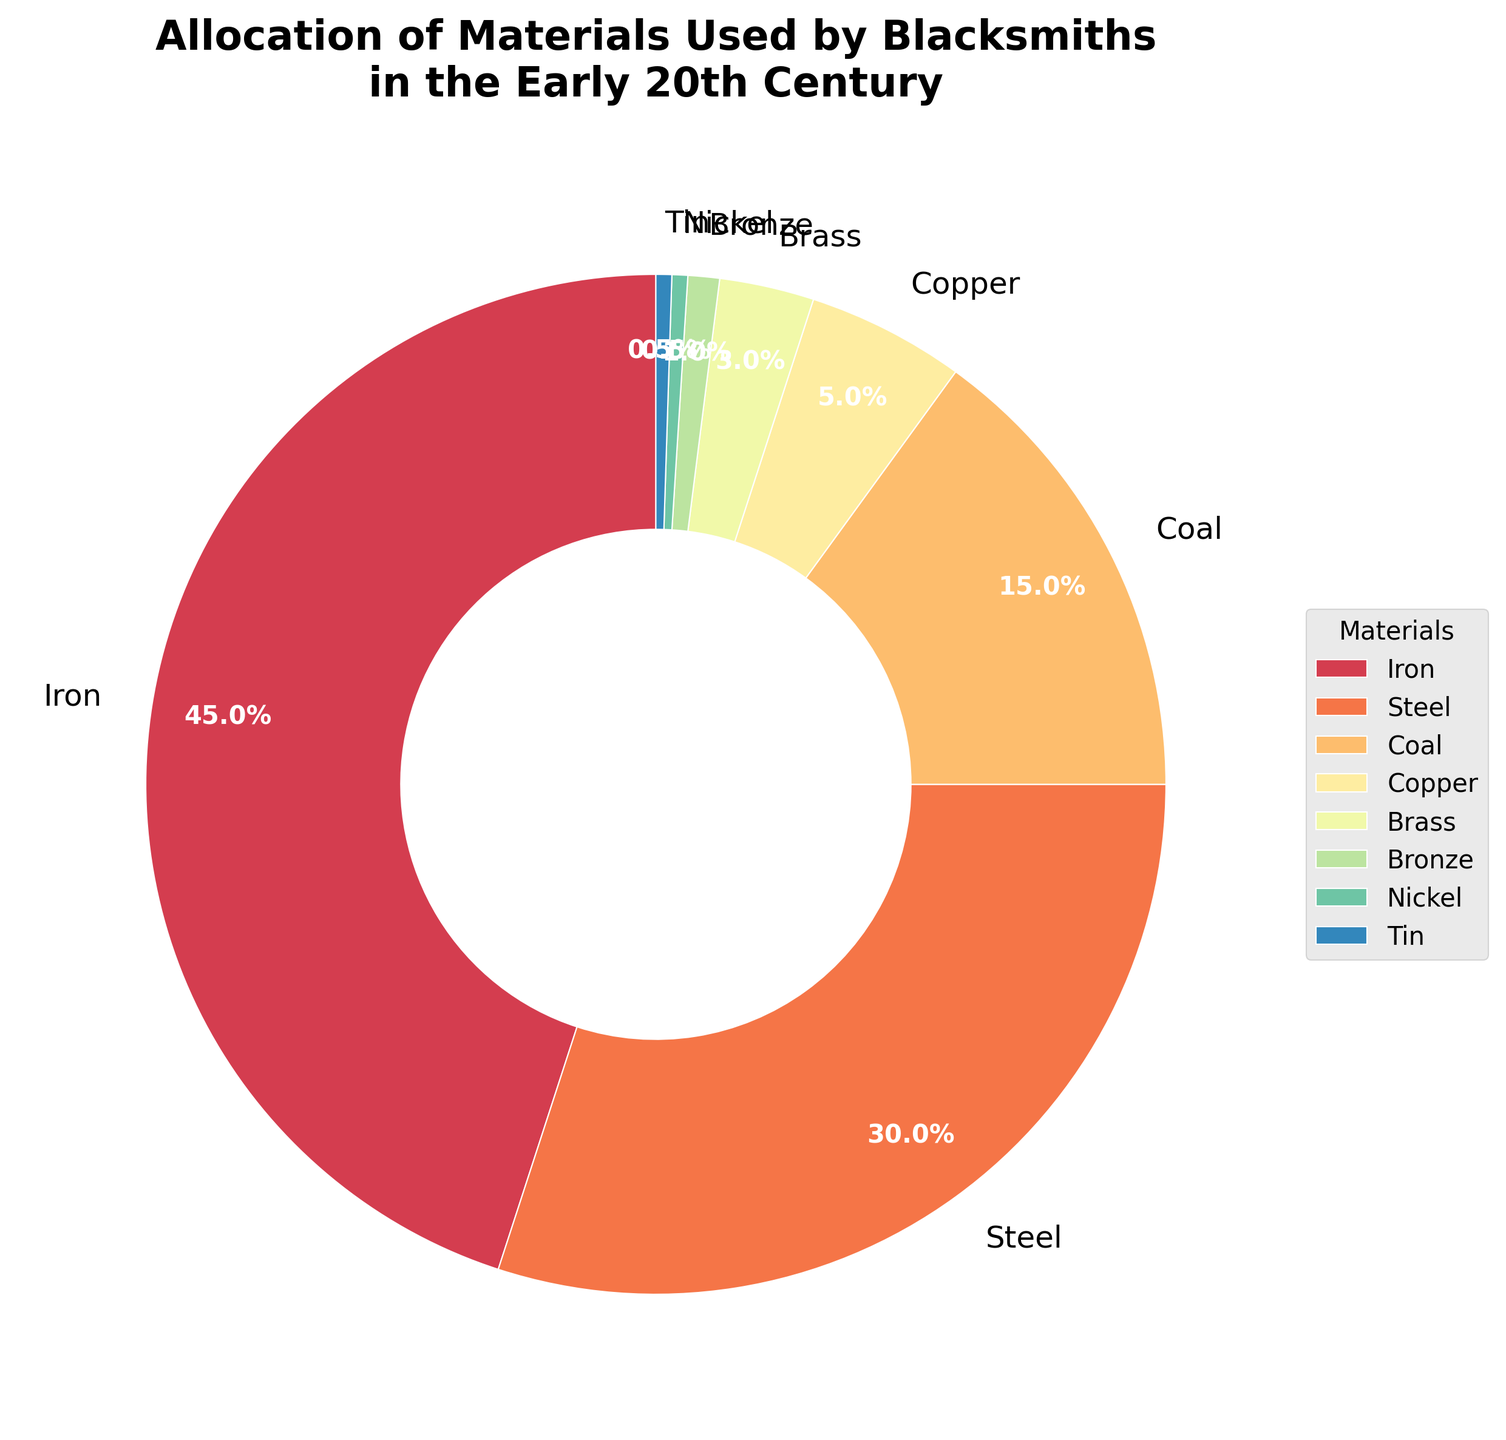Which material makes up the largest percentage? By observing the pie chart, we see that the wedge representing Iron occupies the most significant portion of the chart. The label shows that Iron comprises 45% of the total materials used.
Answer: Iron Which two materials combined make up the same percentage as Steel alone? Steel makes up 30% of the materials. By examining the percentages for other materials, combinations like Copper (5%) and Coal (15%), along with Nickel (0.5%) and Tin (0.5%), fall short. However, when combined, Brass (3%), Bronze (1%), and Copper (5%), these add up to only 9%. The correct answer is Iron at 45%.
Answer: No combination matches exactly Steel Which material has a slightly larger wedge and is next in dominance after Iron? Observing the pie chart reveals that Steel, with a 30% share, has the next largest wedge following Iron's 45%.
Answer: Steel How much more percentage does Coal have compared to Brass? Coal has 15% and Brass has 3%. To find the difference, subtract 3% from 15%. 15% - 3% = 12%.
Answer: 12% What's the combined percentage of Nickel and Tin? By adding the percentages of Nickel (0.5%) and Tin (0.5%), we obtain 0.5% + 0.5% = 1%.
Answer: 1% What’s the average percentage of Bronze and Brass? To determine the average, add 1% (Bronze) and 3% (Brass) to get 4%, then divide this sum by 2. 4% / 2 = 2%.
Answer: 2% Are there any materials that share the same percentage? By observing the pie chart, we note that Nickel and Tin both have exactly 0.5%, making them share the same percentage.
Answer: Yes, Nickel and Tin What colors are used to represent Copper and Bronze? The pie chart in the figure uses a color scheme (like a gradient spectrum) to differentiate between wedges. Copper's wedge appears in a more distinct light shade compared to Bronze's darker shade.
Answer: Light shade for Copper, darker shade for Bronze Which material besides Iron has the least contribution percentage-wise? Besides Iron, the chart shows that both Nickel and Tin have equally the least contribution at 0.5%.
Answer: Nickel and Tin What's the ratio of the percentage of Steel to the percentage of Copper? Steel's percentage is 30%, and Copper's is 5%. To find the ratio, divide 30 by 5. 30%/5% = 6:1.
Answer: 6:1 